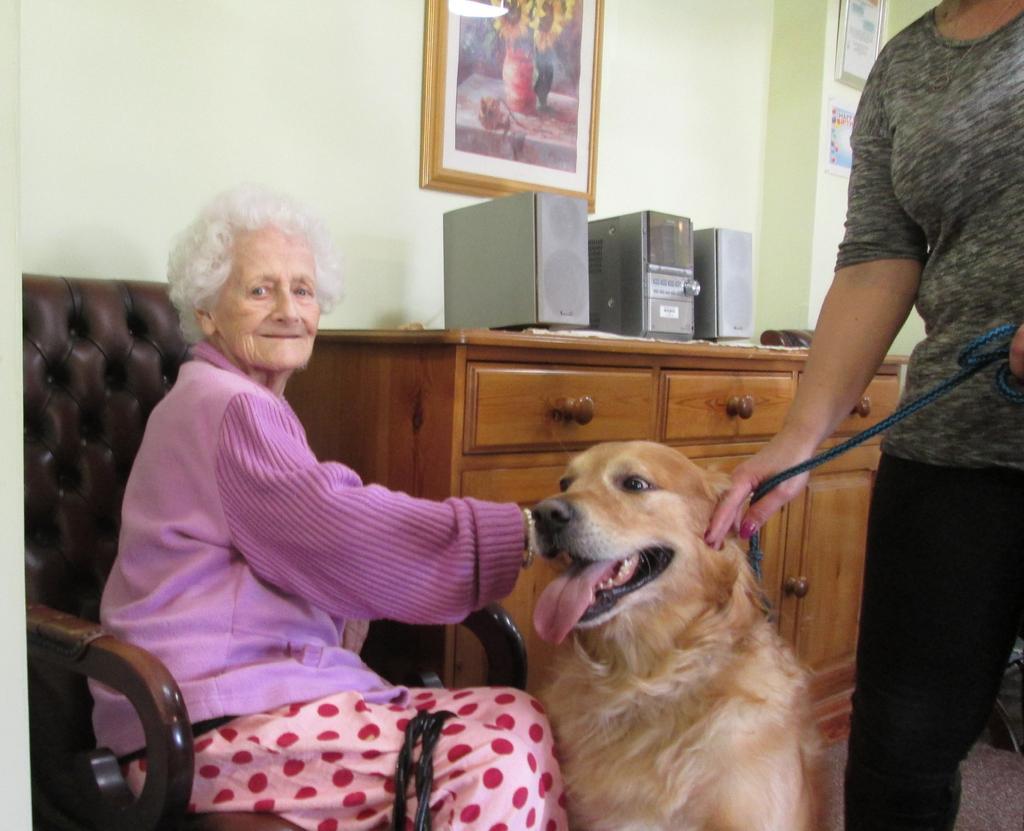In one or two sentences, can you explain what this image depicts? In this there is a woman sitting in the chair and holding the dog. To the right side their is another person who is holding the belt which is tied to the dog. At the background there is music system,photo frame,wall and the cupboard. 